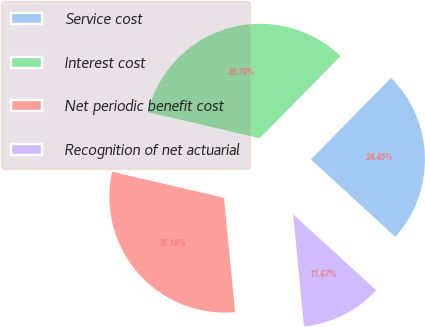Convert chart. <chart><loc_0><loc_0><loc_500><loc_500><pie_chart><fcel>Service cost<fcel>Interest cost<fcel>Net periodic benefit cost<fcel>Recognition of net actuarial<nl><fcel>24.45%<fcel>33.7%<fcel>30.18%<fcel>11.67%<nl></chart> 